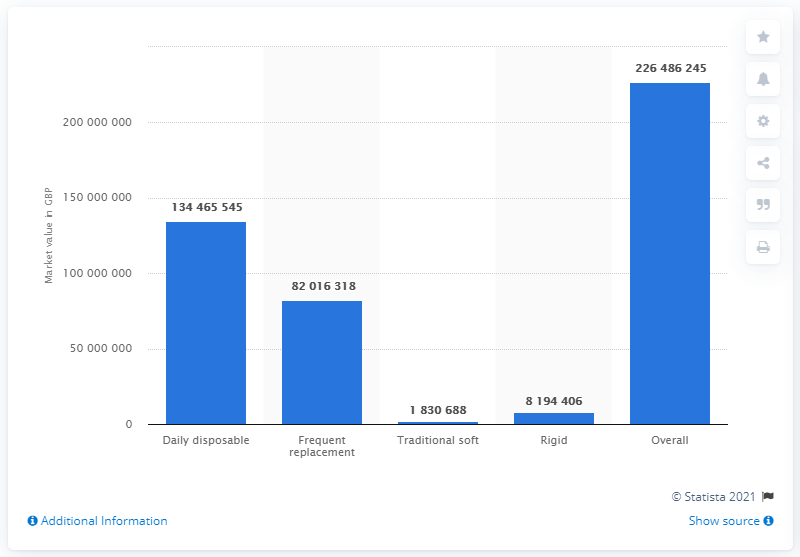List a handful of essential elements in this visual. In 2014, the amount of British pounds spent on disposable contact lenses was 134,465,545. 